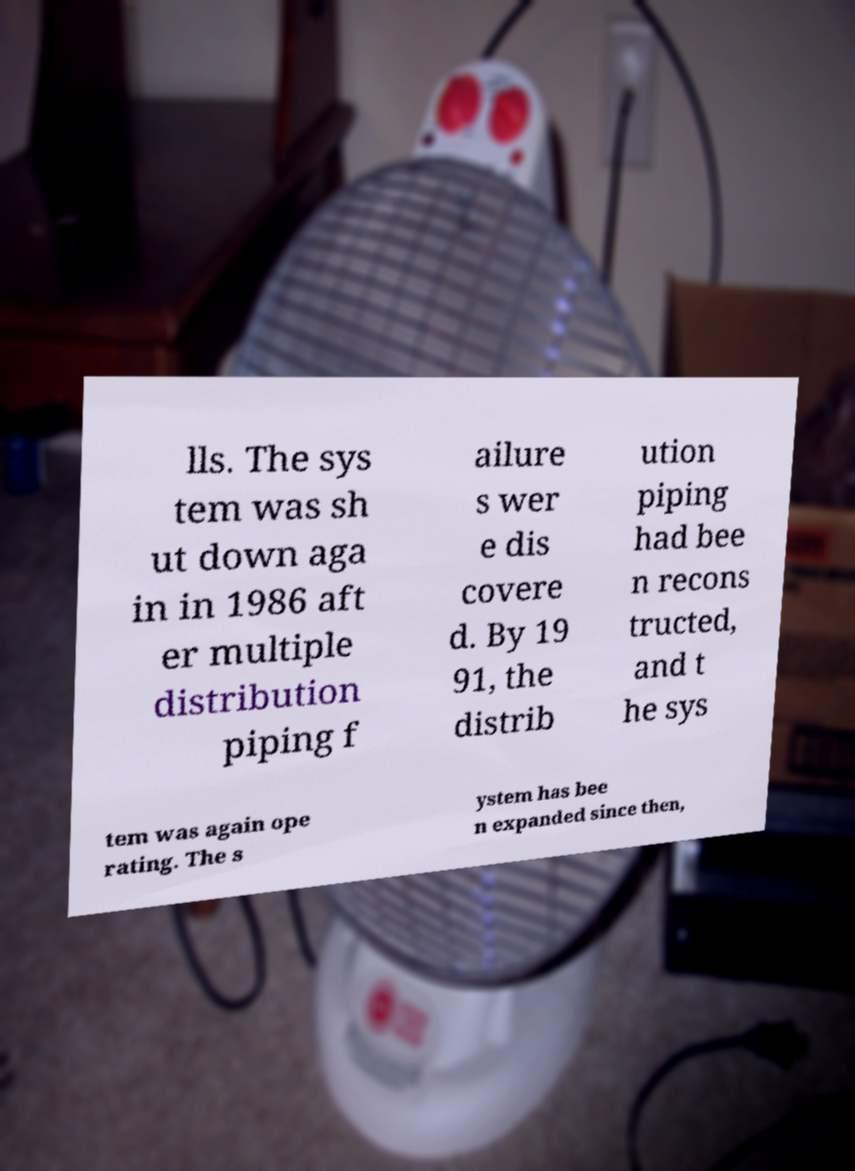Could you assist in decoding the text presented in this image and type it out clearly? lls. The sys tem was sh ut down aga in in 1986 aft er multiple distribution piping f ailure s wer e dis covere d. By 19 91, the distrib ution piping had bee n recons tructed, and t he sys tem was again ope rating. The s ystem has bee n expanded since then, 